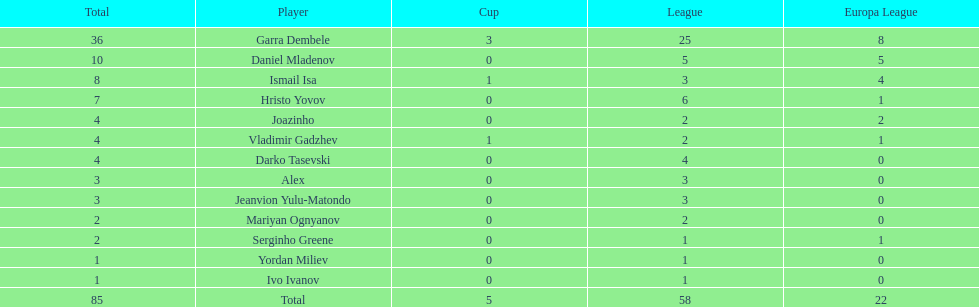Who was the top goalscorer on this team? Garra Dembele. 